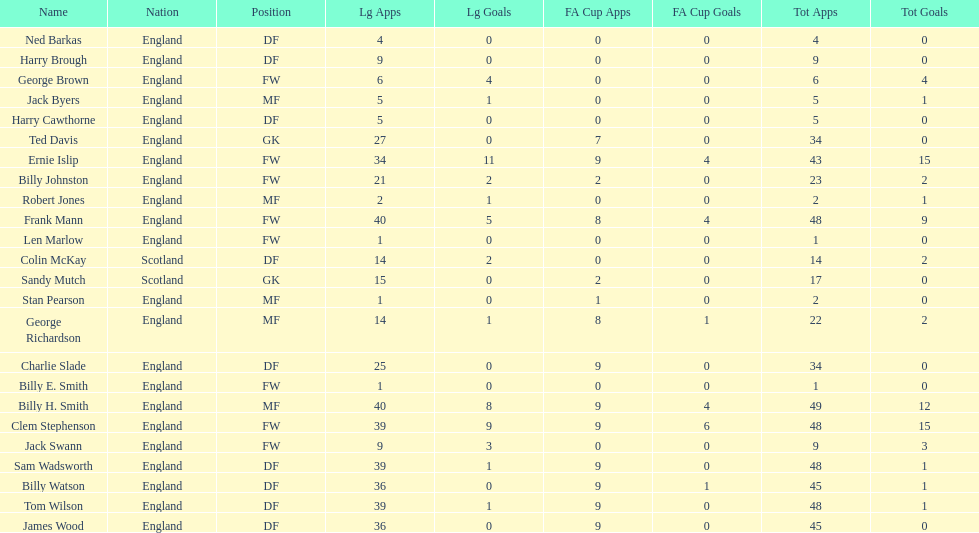What is the first name listed? Ned Barkas. 